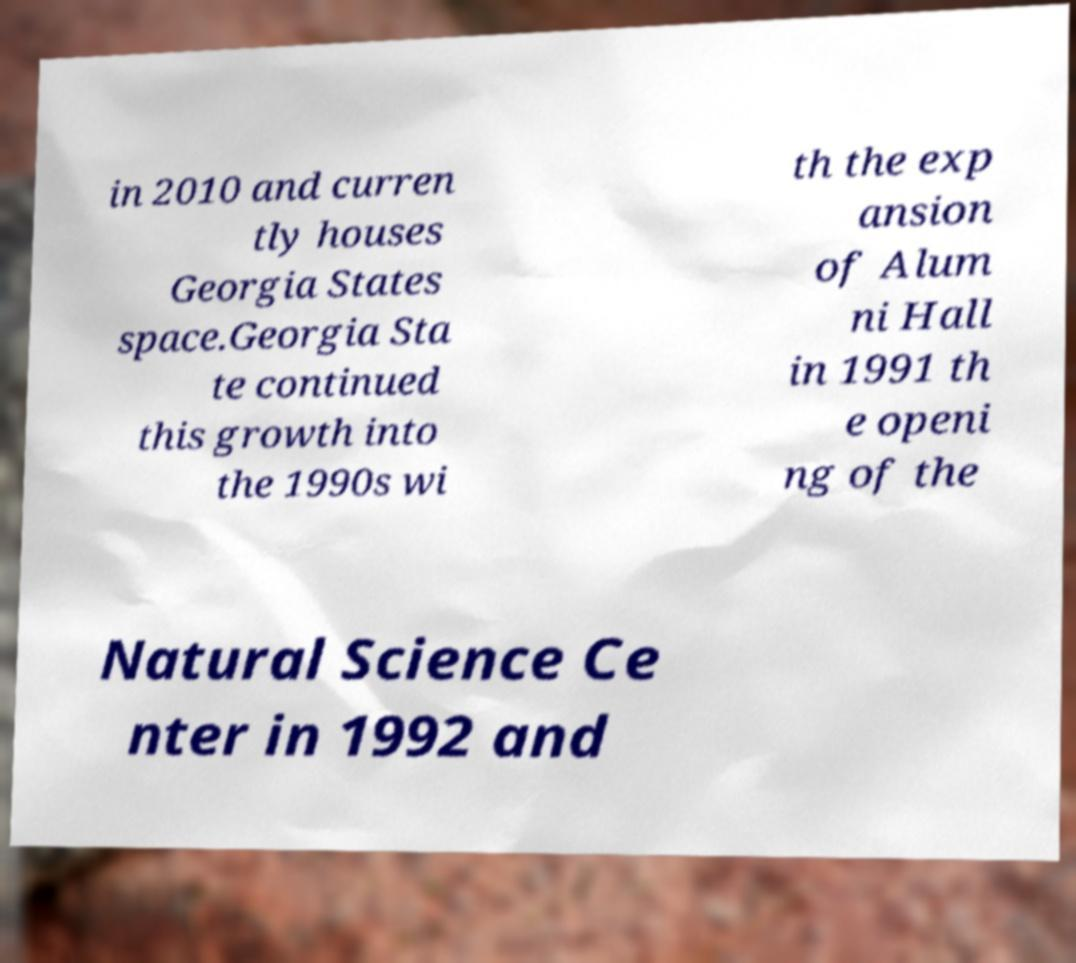Could you assist in decoding the text presented in this image and type it out clearly? in 2010 and curren tly houses Georgia States space.Georgia Sta te continued this growth into the 1990s wi th the exp ansion of Alum ni Hall in 1991 th e openi ng of the Natural Science Ce nter in 1992 and 